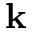<formula> <loc_0><loc_0><loc_500><loc_500>k</formula> 